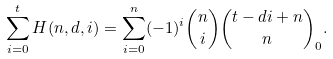Convert formula to latex. <formula><loc_0><loc_0><loc_500><loc_500>\sum _ { i = 0 } ^ { t } H ( n , d , i ) = \sum _ { i = 0 } ^ { n } ( - 1 ) ^ { i } { n \choose i } { t - d i + n \choose n } _ { 0 } .</formula> 